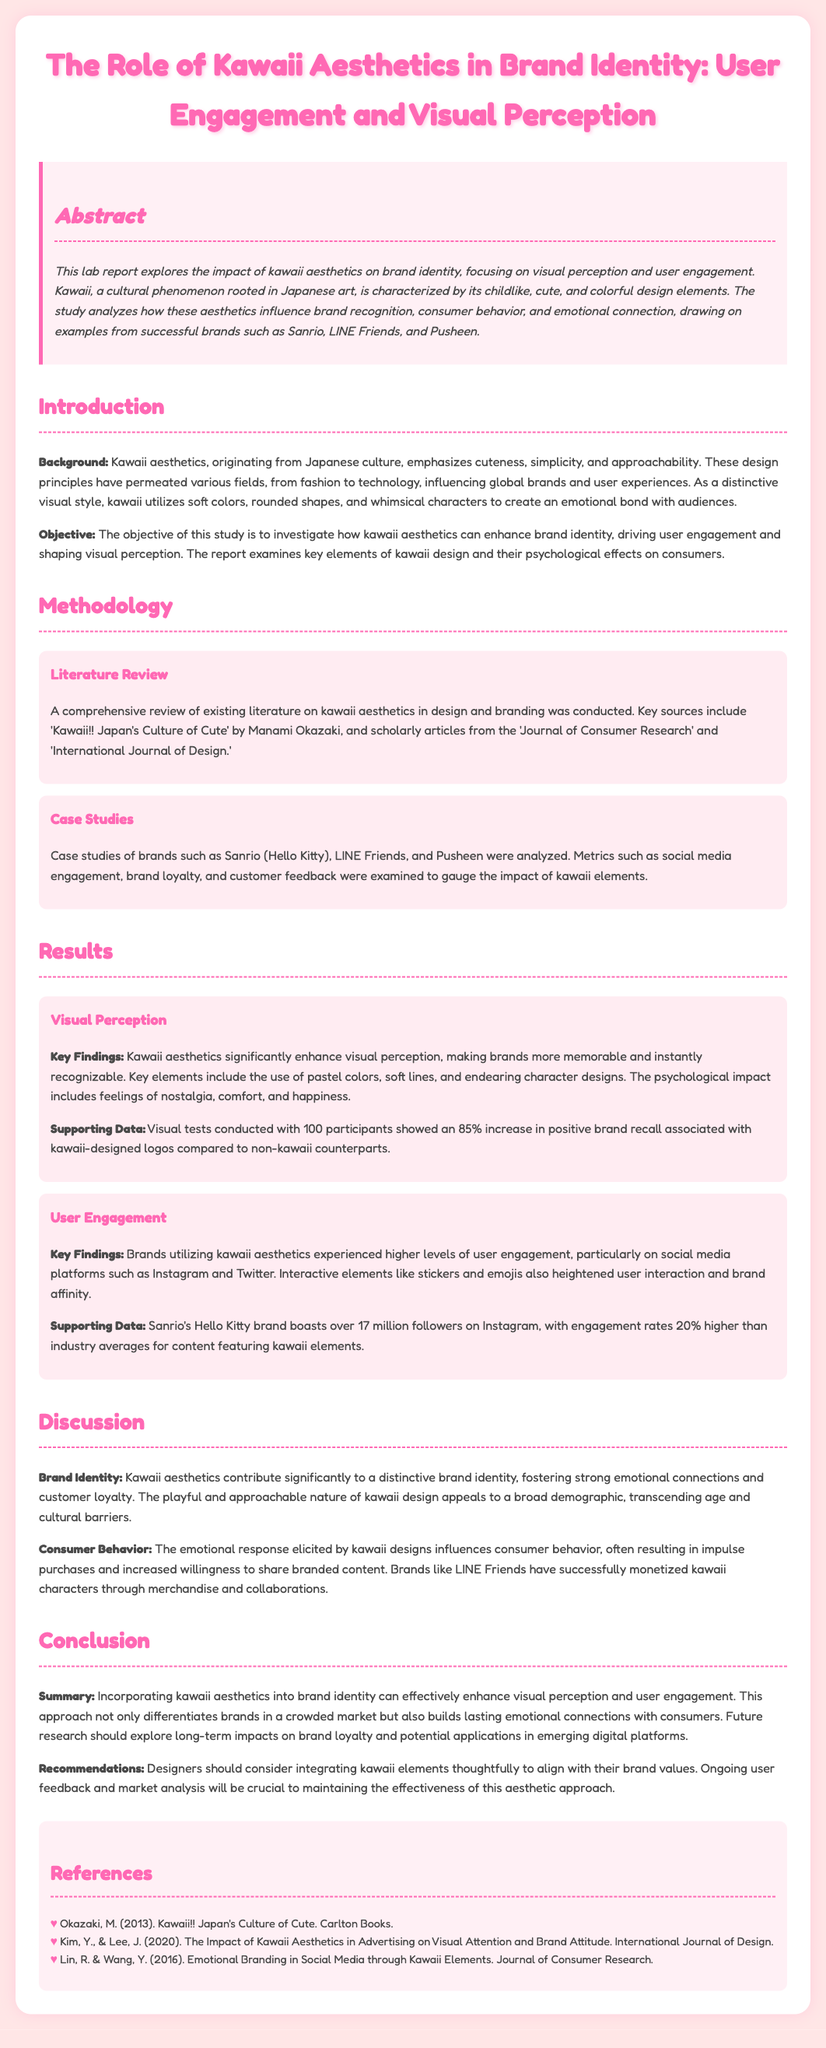what is the title of the lab report? The title is presented prominently at the top of the document.
Answer: The Role of Kawaii Aesthetics in Brand Identity: User Engagement and Visual Perception who are the authors referenced for the literature review? The references in the literature review provide specific names.
Answer: Manami Okazaki, Y. Kim, J. Lee, R. Lin, Y. Wang how many participants were involved in the visual tests? The document explicitly mentions the participant count for the visual tests.
Answer: 100 what percentage increase in positive brand recall is associated with kawaii-designed logos? This percentage is stated in the results section, highlighting a significant finding.
Answer: 85% which brand has over 17 million followers on Instagram? The document specifies the brand noted for its social media following.
Answer: Sanrio what does kawaii aesthetics primarily emphasize? The introduction section outlines the key principles of kawaii aesthetics.
Answer: Cuteness, simplicity, and approachability what emotional responses do kawaii designs elicit? The discussion on consumer behavior describes the impact of kawaii designs.
Answer: Nostalgia, comfort, and happiness what is a recommendation for designers regarding kawaii elements? The recommendations section provides guidance for integrating kawaii aesthetics.
Answer: Align with brand values 